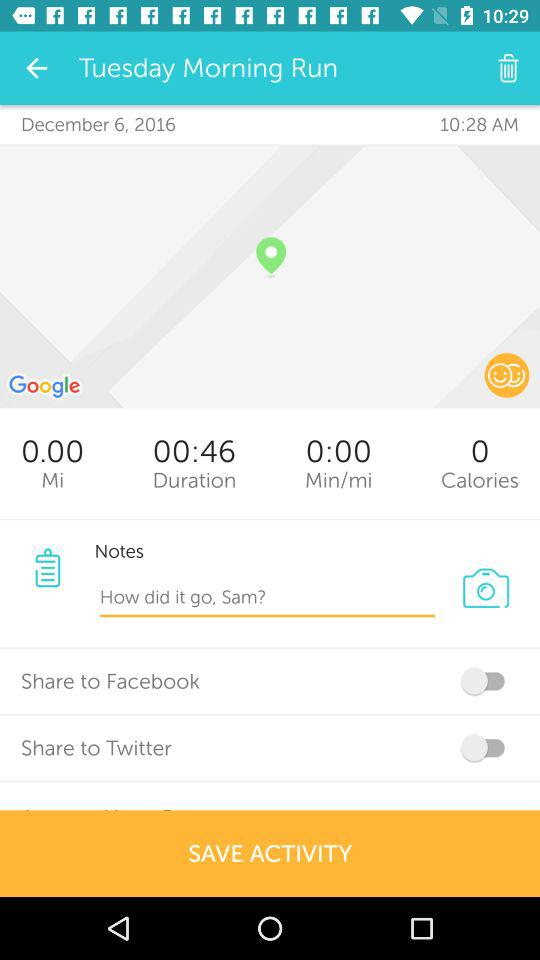What is the duration? The duration is 46 seconds. 